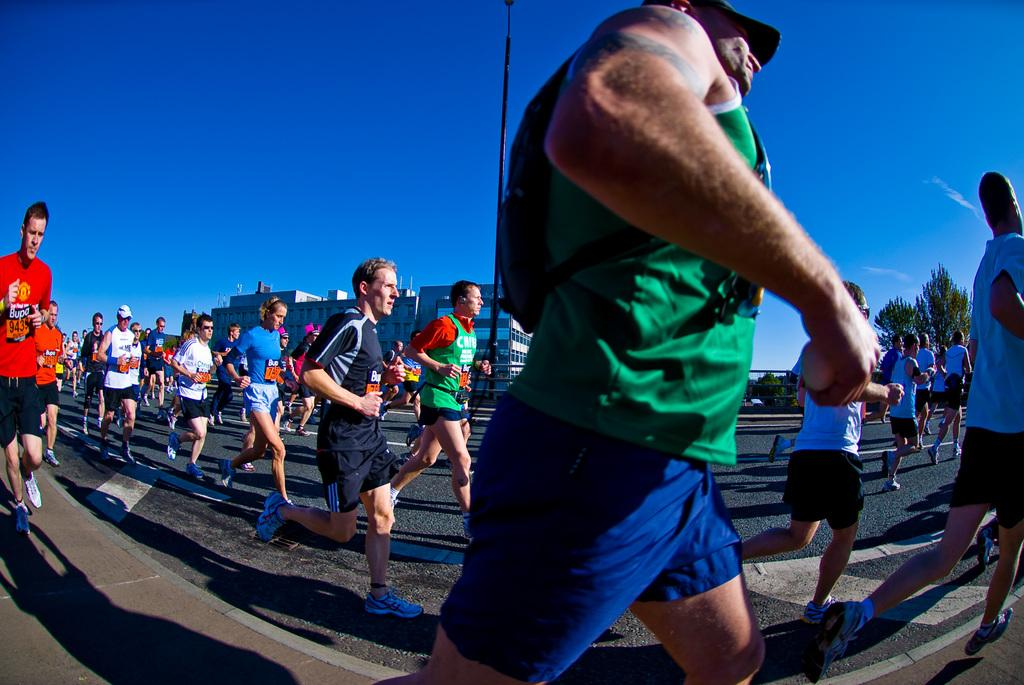What is happening in the image involving a group of people? The people in the image are running on the ground. What can be seen in the background of the image? There are buildings, trees, and the sky visible in the background of the image. What type of plastic material is being used by the squirrel in the image? There is no squirrel present in the image, so it is not possible to determine what type of plastic material it might be using. 